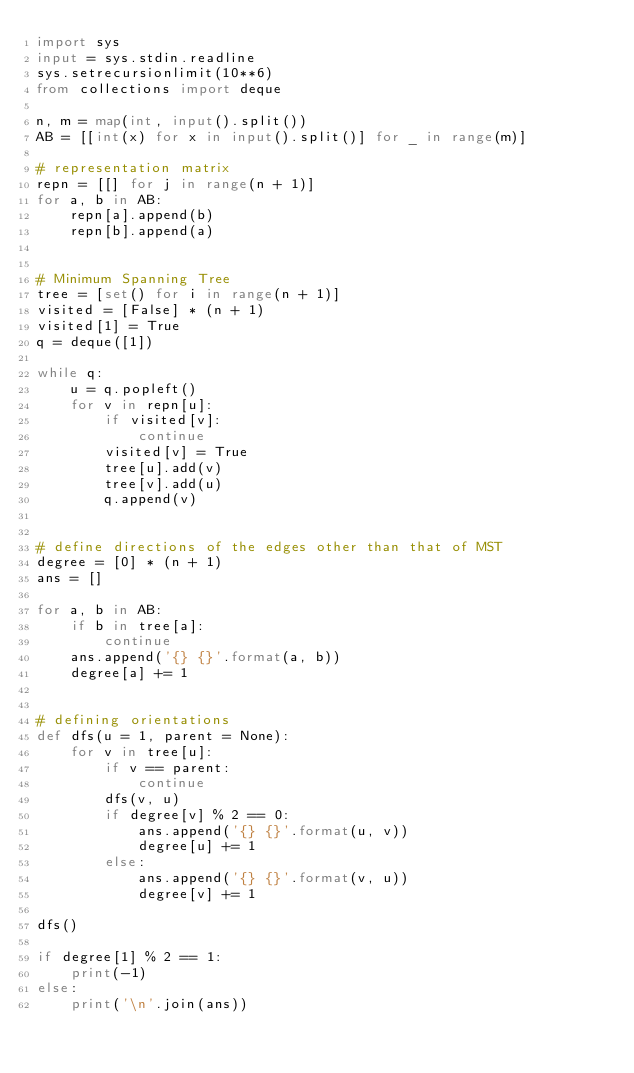<code> <loc_0><loc_0><loc_500><loc_500><_Python_>import sys
input = sys.stdin.readline
sys.setrecursionlimit(10**6)
from collections import deque

n, m = map(int, input().split())
AB = [[int(x) for x in input().split()] for _ in range(m)]

# representation matrix
repn = [[] for j in range(n + 1)]
for a, b in AB:
    repn[a].append(b)
    repn[b].append(a)


# Minimum Spanning Tree
tree = [set() for i in range(n + 1)]
visited = [False] * (n + 1)
visited[1] = True
q = deque([1])

while q:
    u = q.popleft()
    for v in repn[u]:
        if visited[v]:
            continue
        visited[v] = True
        tree[u].add(v)
        tree[v].add(u)
        q.append(v)


# define directions of the edges other than that of MST
degree = [0] * (n + 1)
ans = []

for a, b in AB:
    if b in tree[a]:
        continue
    ans.append('{} {}'.format(a, b))
    degree[a] += 1


# defining orientations
def dfs(u = 1, parent = None):
    for v in tree[u]:
        if v == parent:
            continue
        dfs(v, u)
        if degree[v] % 2 == 0:
            ans.append('{} {}'.format(u, v))
            degree[u] += 1
        else:
            ans.append('{} {}'.format(v, u))
            degree[v] += 1

dfs()

if degree[1] % 2 == 1:
    print(-1)
else:
    print('\n'.join(ans))
</code> 